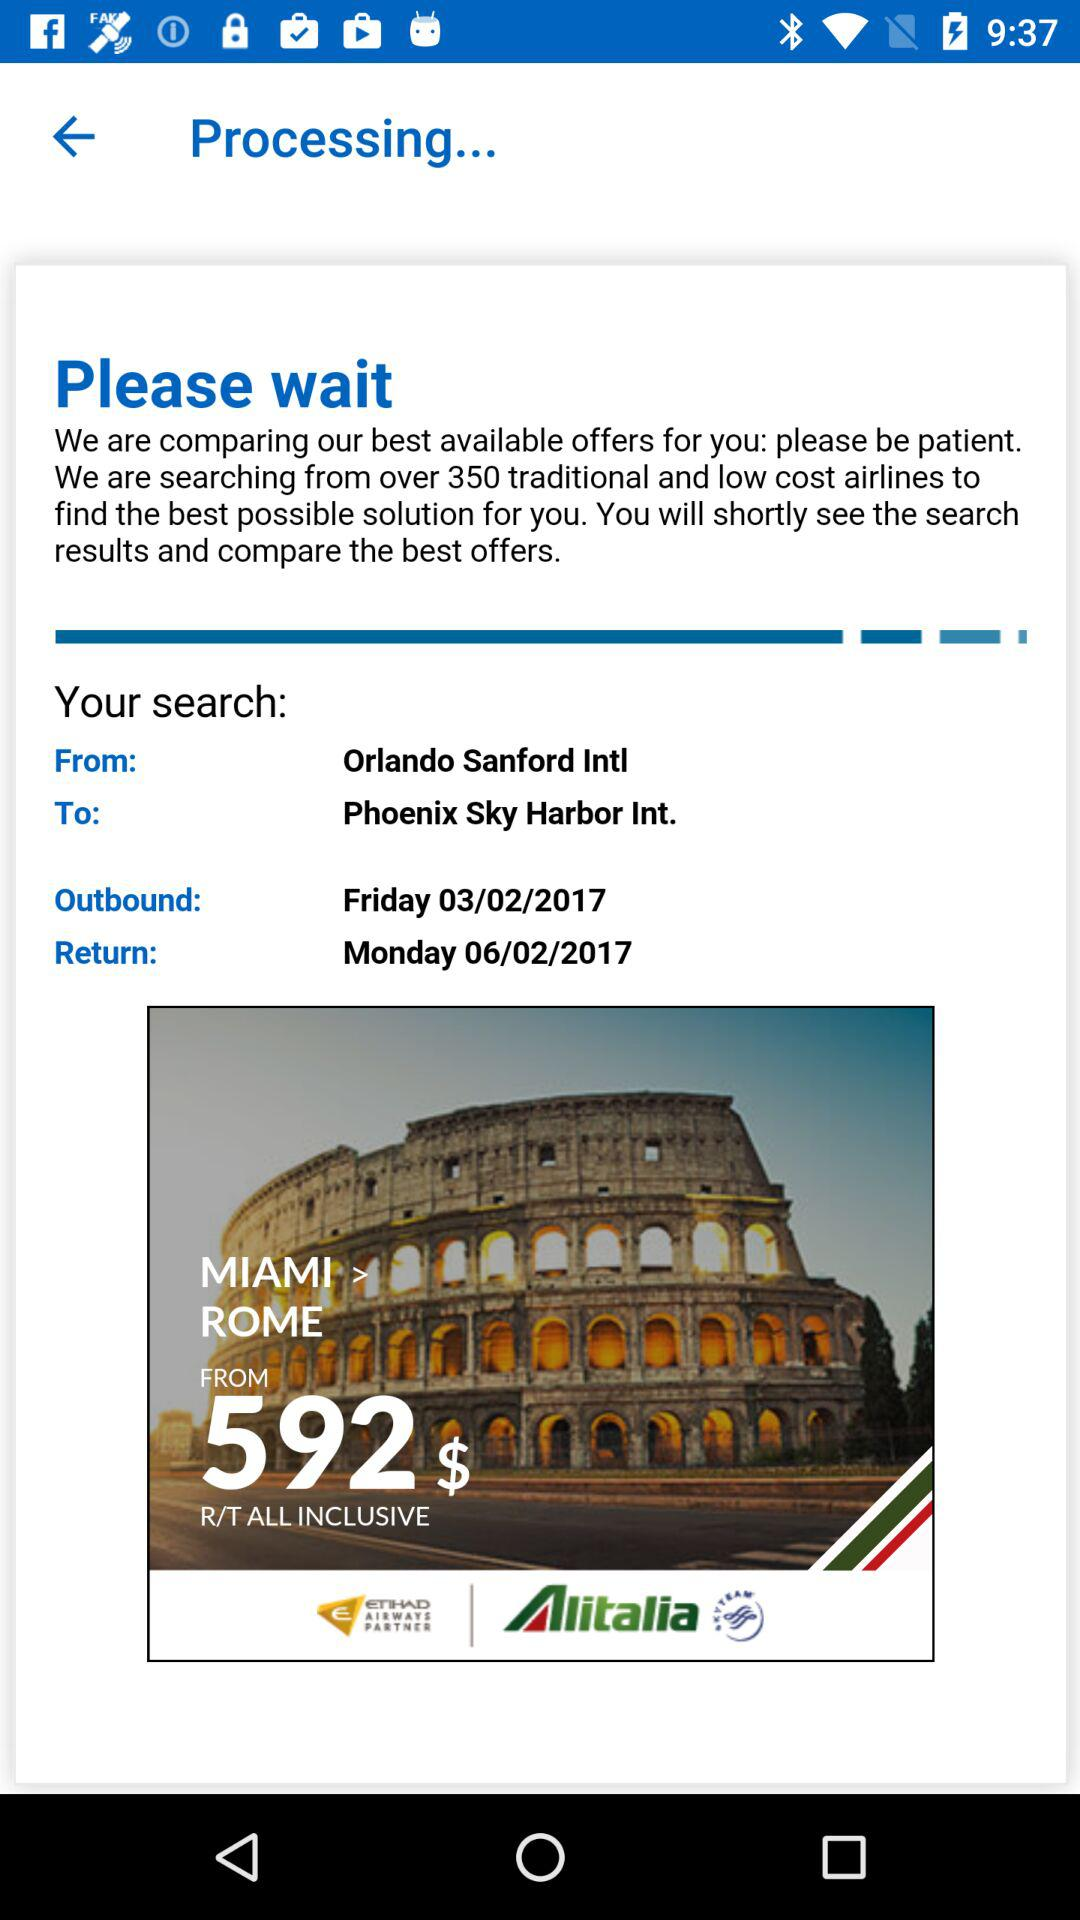What is the outbound date and day? The outbound date and day are March 2, 2017 and Friday, respectively. 